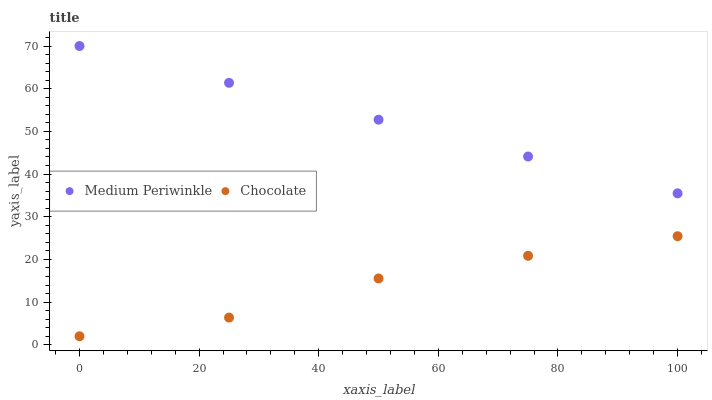Does Chocolate have the minimum area under the curve?
Answer yes or no. Yes. Does Medium Periwinkle have the maximum area under the curve?
Answer yes or no. Yes. Does Chocolate have the maximum area under the curve?
Answer yes or no. No. Is Medium Periwinkle the smoothest?
Answer yes or no. Yes. Is Chocolate the roughest?
Answer yes or no. Yes. Is Chocolate the smoothest?
Answer yes or no. No. Does Chocolate have the lowest value?
Answer yes or no. Yes. Does Medium Periwinkle have the highest value?
Answer yes or no. Yes. Does Chocolate have the highest value?
Answer yes or no. No. Is Chocolate less than Medium Periwinkle?
Answer yes or no. Yes. Is Medium Periwinkle greater than Chocolate?
Answer yes or no. Yes. Does Chocolate intersect Medium Periwinkle?
Answer yes or no. No. 